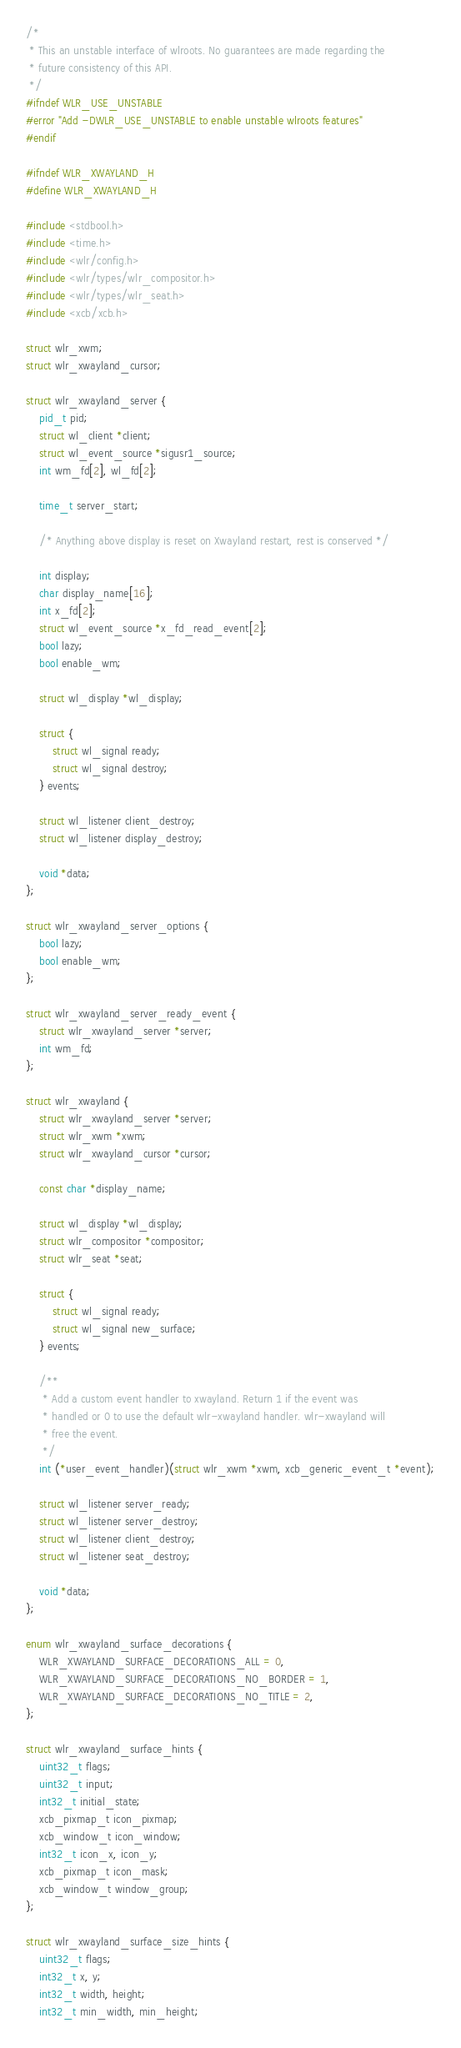<code> <loc_0><loc_0><loc_500><loc_500><_C_>/*
 * This an unstable interface of wlroots. No guarantees are made regarding the
 * future consistency of this API.
 */
#ifndef WLR_USE_UNSTABLE
#error "Add -DWLR_USE_UNSTABLE to enable unstable wlroots features"
#endif

#ifndef WLR_XWAYLAND_H
#define WLR_XWAYLAND_H

#include <stdbool.h>
#include <time.h>
#include <wlr/config.h>
#include <wlr/types/wlr_compositor.h>
#include <wlr/types/wlr_seat.h>
#include <xcb/xcb.h>

struct wlr_xwm;
struct wlr_xwayland_cursor;

struct wlr_xwayland_server {
	pid_t pid;
	struct wl_client *client;
	struct wl_event_source *sigusr1_source;
	int wm_fd[2], wl_fd[2];

	time_t server_start;

	/* Anything above display is reset on Xwayland restart, rest is conserved */

	int display;
	char display_name[16];
	int x_fd[2];
	struct wl_event_source *x_fd_read_event[2];
	bool lazy;
	bool enable_wm;

	struct wl_display *wl_display;

	struct {
		struct wl_signal ready;
		struct wl_signal destroy;
	} events;

	struct wl_listener client_destroy;
	struct wl_listener display_destroy;

	void *data;
};

struct wlr_xwayland_server_options {
	bool lazy;
	bool enable_wm;
};

struct wlr_xwayland_server_ready_event {
	struct wlr_xwayland_server *server;
	int wm_fd;
};

struct wlr_xwayland {
	struct wlr_xwayland_server *server;
	struct wlr_xwm *xwm;
	struct wlr_xwayland_cursor *cursor;

	const char *display_name;

	struct wl_display *wl_display;
	struct wlr_compositor *compositor;
	struct wlr_seat *seat;

	struct {
		struct wl_signal ready;
		struct wl_signal new_surface;
	} events;

	/**
	 * Add a custom event handler to xwayland. Return 1 if the event was
	 * handled or 0 to use the default wlr-xwayland handler. wlr-xwayland will
	 * free the event.
	 */
	int (*user_event_handler)(struct wlr_xwm *xwm, xcb_generic_event_t *event);

	struct wl_listener server_ready;
	struct wl_listener server_destroy;
	struct wl_listener client_destroy;
	struct wl_listener seat_destroy;

	void *data;
};

enum wlr_xwayland_surface_decorations {
	WLR_XWAYLAND_SURFACE_DECORATIONS_ALL = 0,
	WLR_XWAYLAND_SURFACE_DECORATIONS_NO_BORDER = 1,
	WLR_XWAYLAND_SURFACE_DECORATIONS_NO_TITLE = 2,
};

struct wlr_xwayland_surface_hints {
	uint32_t flags;
	uint32_t input;
	int32_t initial_state;
	xcb_pixmap_t icon_pixmap;
	xcb_window_t icon_window;
	int32_t icon_x, icon_y;
	xcb_pixmap_t icon_mask;
	xcb_window_t window_group;
};

struct wlr_xwayland_surface_size_hints {
	uint32_t flags;
	int32_t x, y;
	int32_t width, height;
	int32_t min_width, min_height;</code> 